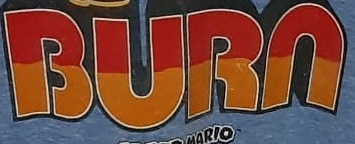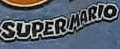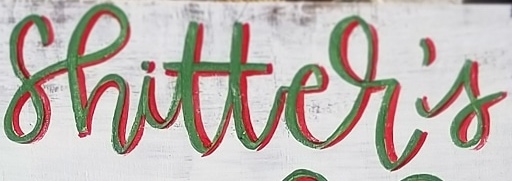Read the text from these images in sequence, separated by a semicolon. BURN; SUPERMARIO; shitter's 